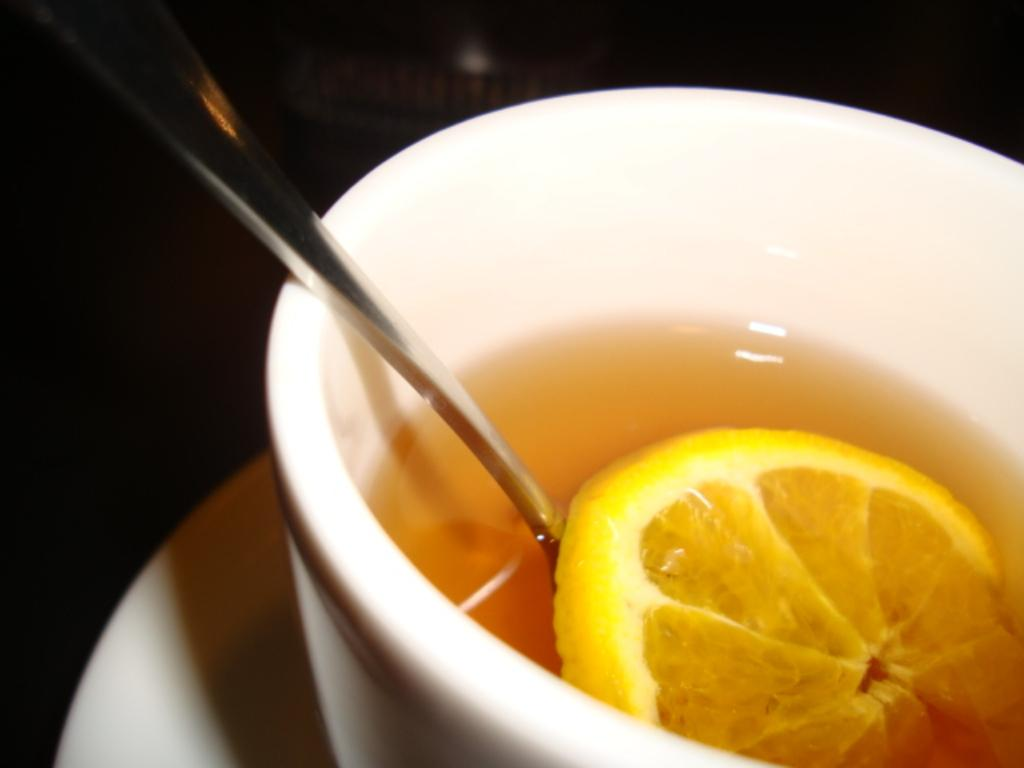What is the color of the saucer in the image? The saucer in the image is white. What is placed on top of the saucer? There is a bowl on the saucer. What is inside the bowl? There is soup in the bowl. What utensil is present in the soup? A spoon is present in the soup. What additional ingredient can be seen in the soup? A lemon slice is in the soup. What type of wax can be seen melting in the soup? There is no wax present in the image; it is a bowl of soup with a spoon and a lemon slice. How does the bucket affect the taste of the soup in the image? There is no bucket present in the image, so it cannot affect the taste of the soup. 